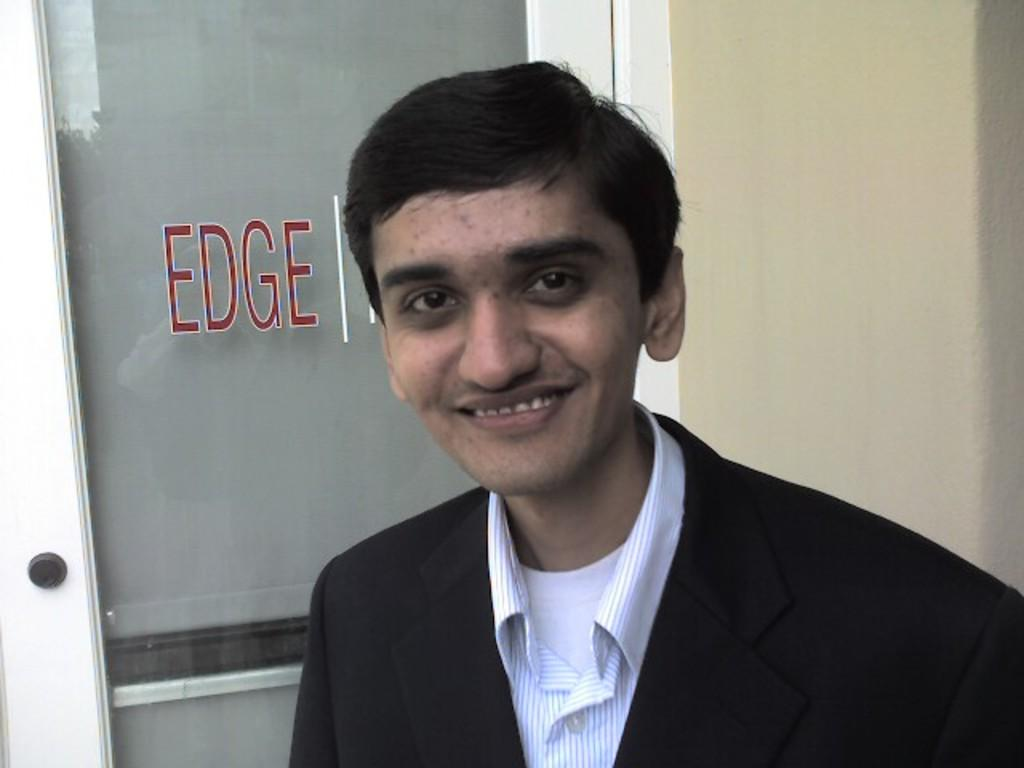Who is present in the image? There is a man in the image. What is the man's facial expression? The man is smiling. What can be seen on the left side of the image? There is a door on the left side of the image. What is visible in the image besides the man and the door? There is text visible in the image, and there is a wall in the background. What type of pie is the scarecrow holding in the image? There is no scarecrow or pie present in the image. How many train tracks can be seen in the image? There are no train tracks visible in the image. 